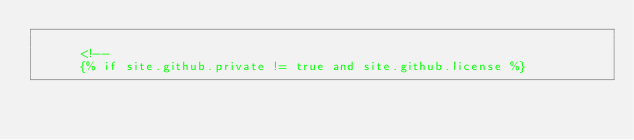Convert code to text. <code><loc_0><loc_0><loc_500><loc_500><_HTML_>
      <!--
      {% if site.github.private != true and site.github.license %}      </code> 